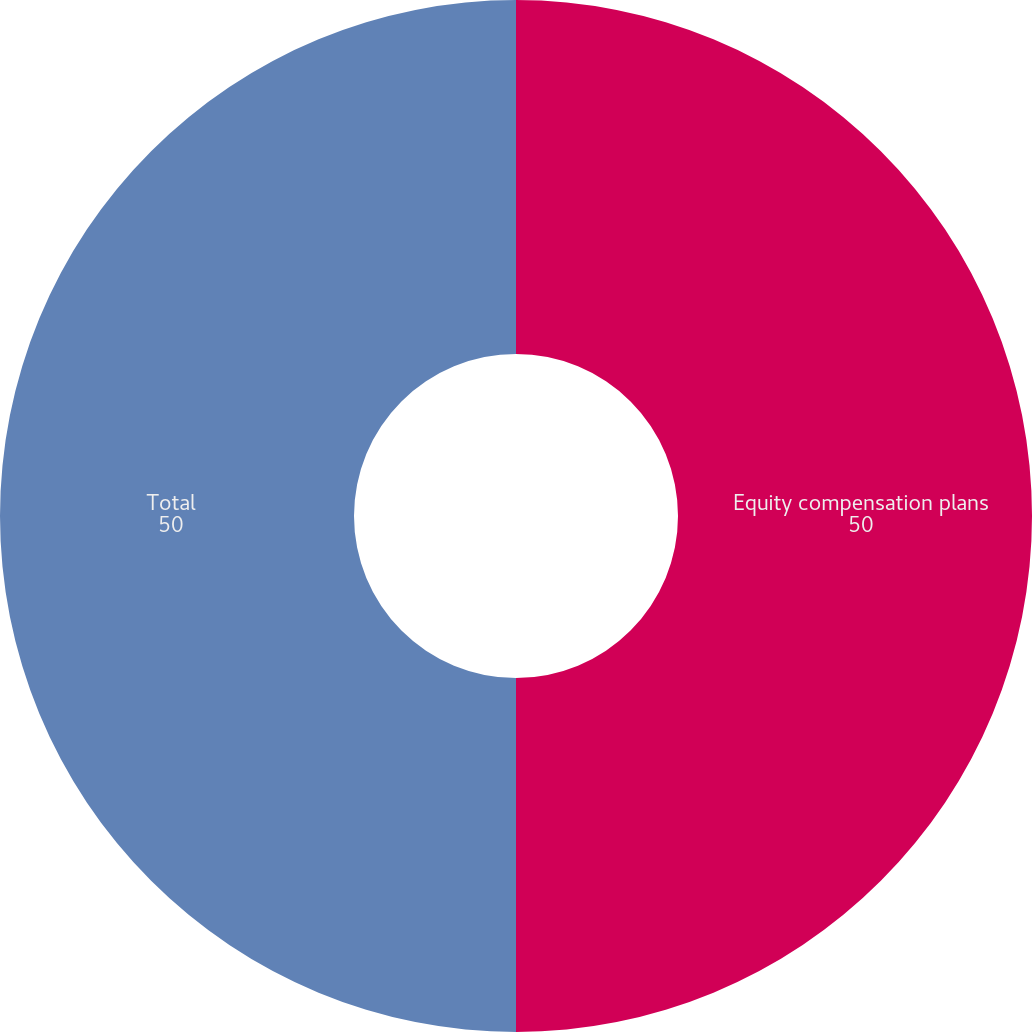<chart> <loc_0><loc_0><loc_500><loc_500><pie_chart><fcel>Equity compensation plans<fcel>Total<nl><fcel>50.0%<fcel>50.0%<nl></chart> 